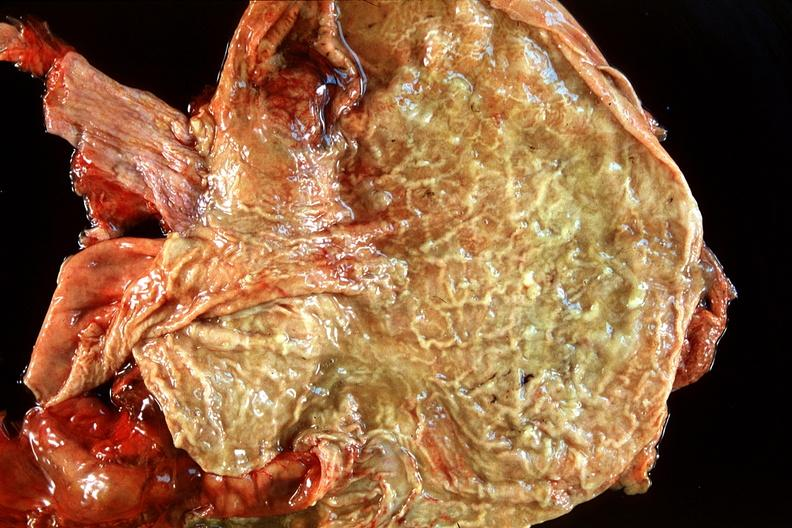does mucoepidermoid carcinoma show normal stomach?
Answer the question using a single word or phrase. No 